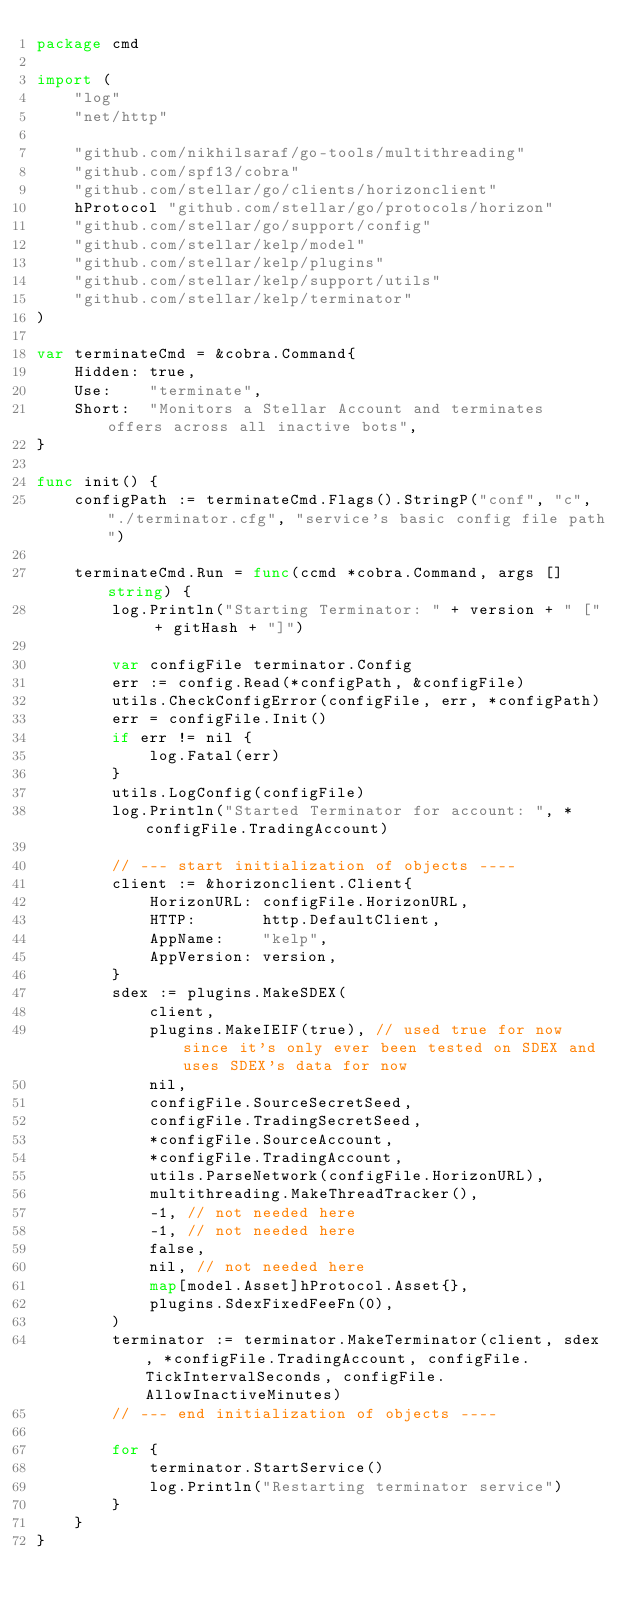<code> <loc_0><loc_0><loc_500><loc_500><_Go_>package cmd

import (
	"log"
	"net/http"

	"github.com/nikhilsaraf/go-tools/multithreading"
	"github.com/spf13/cobra"
	"github.com/stellar/go/clients/horizonclient"
	hProtocol "github.com/stellar/go/protocols/horizon"
	"github.com/stellar/go/support/config"
	"github.com/stellar/kelp/model"
	"github.com/stellar/kelp/plugins"
	"github.com/stellar/kelp/support/utils"
	"github.com/stellar/kelp/terminator"
)

var terminateCmd = &cobra.Command{
	Hidden: true,
	Use:    "terminate",
	Short:  "Monitors a Stellar Account and terminates offers across all inactive bots",
}

func init() {
	configPath := terminateCmd.Flags().StringP("conf", "c", "./terminator.cfg", "service's basic config file path")

	terminateCmd.Run = func(ccmd *cobra.Command, args []string) {
		log.Println("Starting Terminator: " + version + " [" + gitHash + "]")

		var configFile terminator.Config
		err := config.Read(*configPath, &configFile)
		utils.CheckConfigError(configFile, err, *configPath)
		err = configFile.Init()
		if err != nil {
			log.Fatal(err)
		}
		utils.LogConfig(configFile)
		log.Println("Started Terminator for account: ", *configFile.TradingAccount)

		// --- start initialization of objects ----
		client := &horizonclient.Client{
			HorizonURL: configFile.HorizonURL,
			HTTP:       http.DefaultClient,
			AppName:    "kelp",
			AppVersion: version,
		}
		sdex := plugins.MakeSDEX(
			client,
			plugins.MakeIEIF(true), // used true for now since it's only ever been tested on SDEX and uses SDEX's data for now
			nil,
			configFile.SourceSecretSeed,
			configFile.TradingSecretSeed,
			*configFile.SourceAccount,
			*configFile.TradingAccount,
			utils.ParseNetwork(configFile.HorizonURL),
			multithreading.MakeThreadTracker(),
			-1, // not needed here
			-1, // not needed here
			false,
			nil, // not needed here
			map[model.Asset]hProtocol.Asset{},
			plugins.SdexFixedFeeFn(0),
		)
		terminator := terminator.MakeTerminator(client, sdex, *configFile.TradingAccount, configFile.TickIntervalSeconds, configFile.AllowInactiveMinutes)
		// --- end initialization of objects ----

		for {
			terminator.StartService()
			log.Println("Restarting terminator service")
		}
	}
}
</code> 